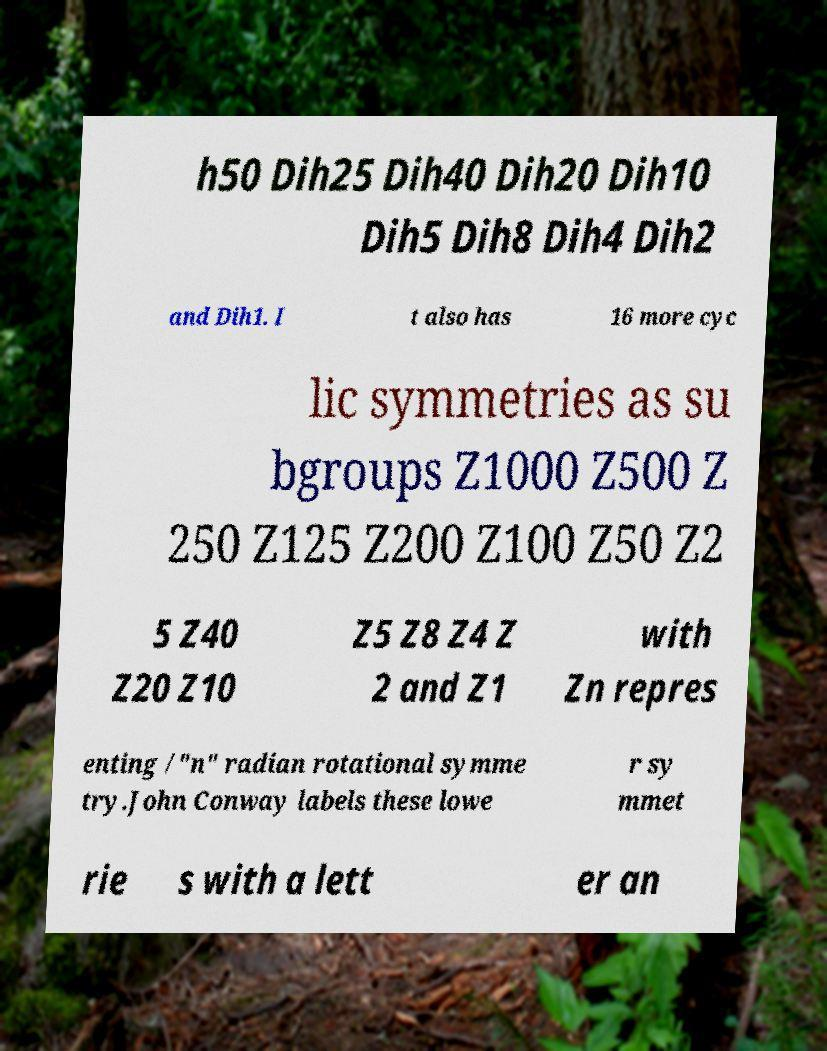Can you read and provide the text displayed in the image?This photo seems to have some interesting text. Can you extract and type it out for me? h50 Dih25 Dih40 Dih20 Dih10 Dih5 Dih8 Dih4 Dih2 and Dih1. I t also has 16 more cyc lic symmetries as su bgroups Z1000 Z500 Z 250 Z125 Z200 Z100 Z50 Z2 5 Z40 Z20 Z10 Z5 Z8 Z4 Z 2 and Z1 with Zn repres enting /"n" radian rotational symme try.John Conway labels these lowe r sy mmet rie s with a lett er an 